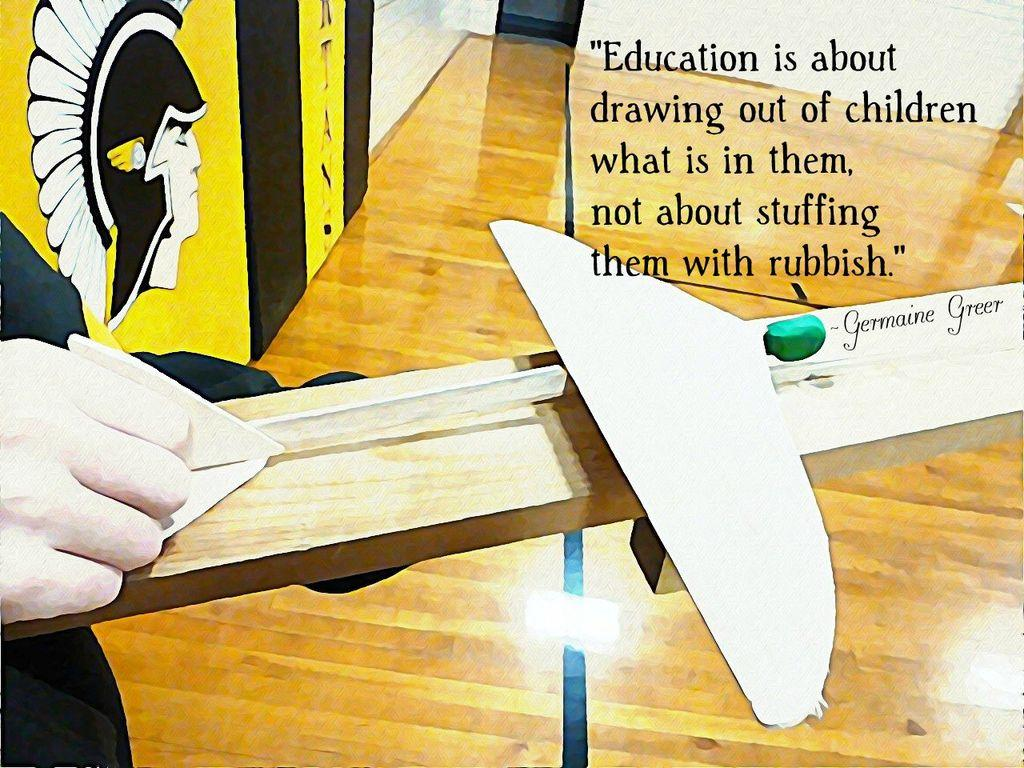<image>
Describe the image concisely. Germaine Greer wrote on a stick with a quote about Education is all about drawing out of children what is in them. 